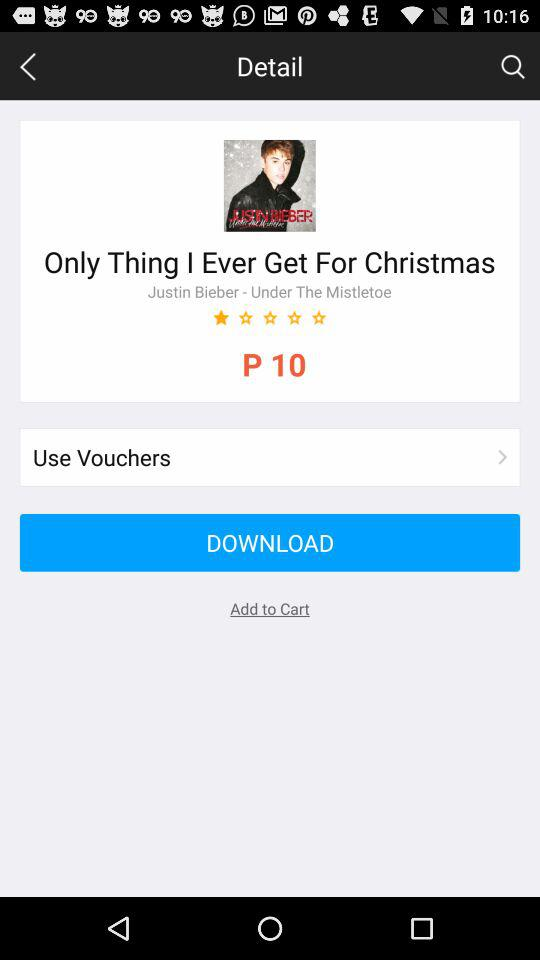How many people liked "Only Thing I Ever Get For Christmas"?
When the provided information is insufficient, respond with <no answer>. <no answer> 